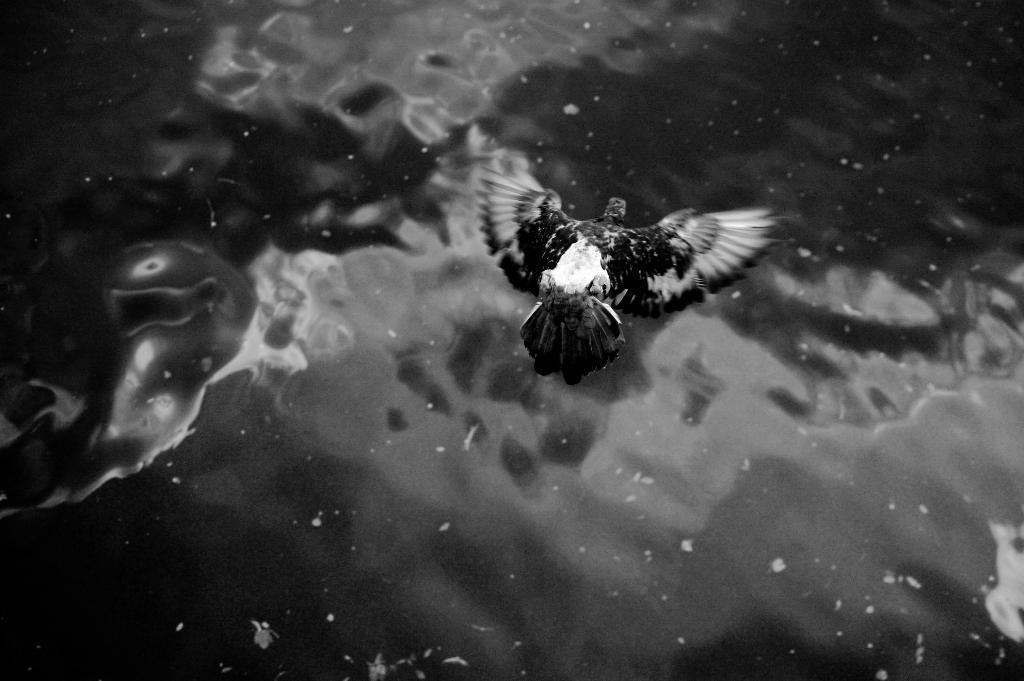In one or two sentences, can you explain what this image depicts? This is a black and white image where we can see a bird is flying in the air. Here we can see the water. 